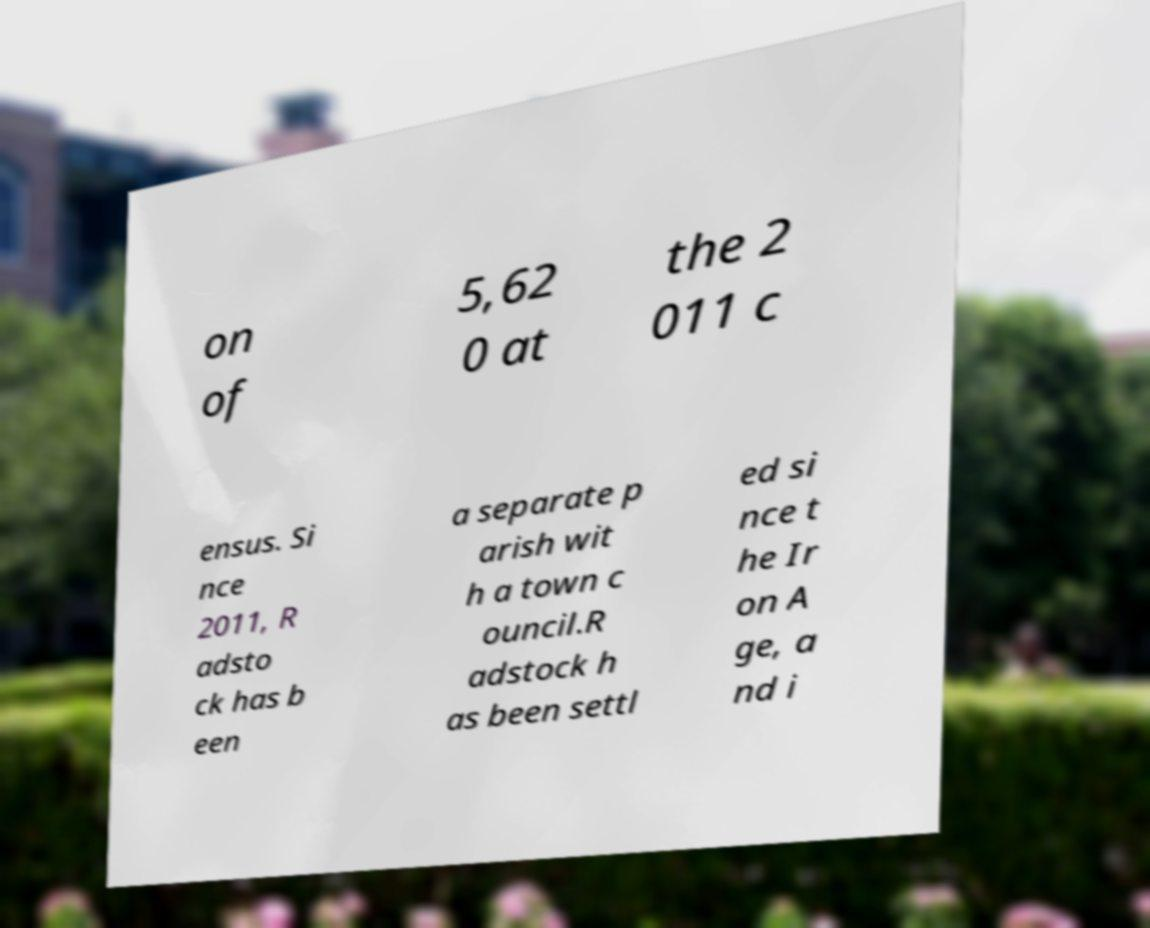Can you accurately transcribe the text from the provided image for me? on of 5,62 0 at the 2 011 c ensus. Si nce 2011, R adsto ck has b een a separate p arish wit h a town c ouncil.R adstock h as been settl ed si nce t he Ir on A ge, a nd i 